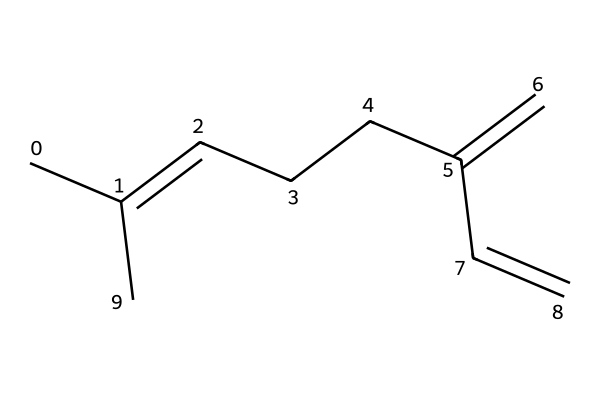What is the total number of carbon atoms in this compound? By examining the SMILES representation, we can count the carbon (C) symbols. Each "C" in the notation represents a carbon atom, and in this structure, there are a total of 15 carbon atoms present.
Answer: 15 How many double bonds are present in the structure? The presence of double bonds can be identified by looking for "=" signs in the SMILES notation. In this case, there are three "=" signs, indicating the presence of three double bonds in the structure.
Answer: 3 What is the longest continuous chain of carbon atoms in this molecule? To determine the longest continuous chain, we trace the structure from one end to another while counting. Starting from the leftmost carbon and moving along the main chain, we find that the longest chain consists of seven carbon atoms.
Answer: 7 What type of hydrocarbon is represented by this compound? By analyzing the structure, we note that it contains only carbon and hydrogen atoms, and the presence of multiple double bonds classifies it specifically as an unsaturated hydrocarbon.
Answer: unsaturated Would this compound likely have a high or low flash point? This compound is categorized as a flammable liquid, and typically, liquids that have many double bonds (like this one) tend to have lower flash points due to their higher volatility. Thus, we conclude that it likely has a low flash point.
Answer: low What is the structural feature that contributes to its flammable nature? The presence of multiple carbon-carbon double bonds within the structure increases the chemical's reactivity with oxygen, leading to combustion. This inherent instability in saturated bonds correlates with its flammable properties.
Answer: double bonds 